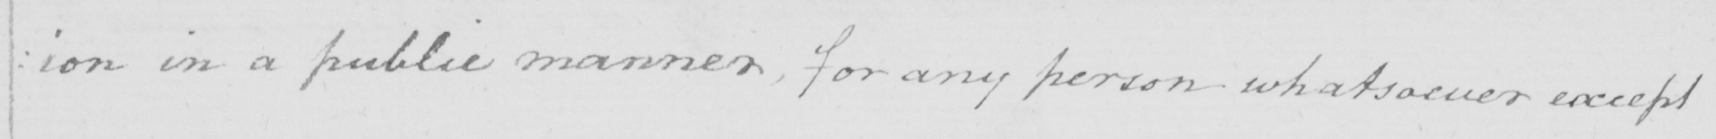Can you read and transcribe this handwriting? : ion in a public manner , for any person whatsoever except 